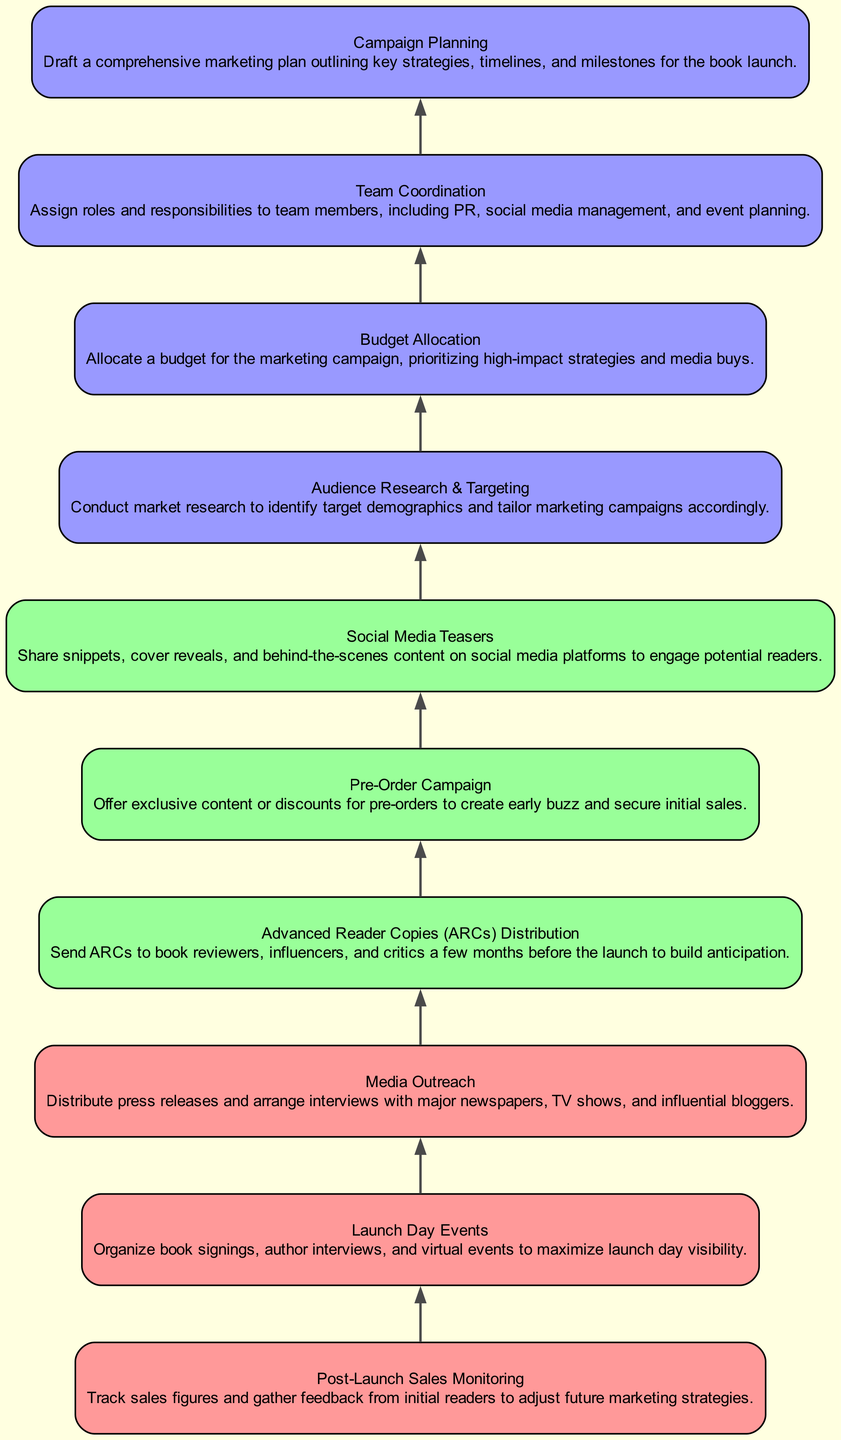What is the first step in the workflow? The first step in the workflow is found at the bottom of the flow chart, which is "Campaign Planning." This step outlines the marketing plan before any actions are taken.
Answer: Campaign Planning How many total nodes are in the diagram? To count the total nodes, we can look at the individual steps listed. There are ten steps from "Campaign Planning" to "Post-Launch Sales Monitoring," indicating there are ten nodes in total.
Answer: Ten Which step follows "Media Outreach"? "Advanced Reader Copies (ARCs) Distribution" immediately follows "Media Outreach" in the flow chart, suggesting that these actions are sequential in the marketing campaign workflow.
Answer: Advanced Reader Copies (ARCs) Distribution What color is used for the final steps of the workflow? The final steps, specifically the last three nodes of the chart, are colored light red, indicating that they are important final actions to be taken after pre-launch activities.
Answer: Light red Which step involves assigning roles to team members? The step titled "Team Coordination" is responsible for assigning roles and responsibilities to team members, ensuring clear delineation of tasks before the launch.
Answer: Team Coordination What type of event is planned on launch day? The flow chart indicates that there are "Launch Day Events," which involve book signings and author interviews to maximize visibility on the launch day.
Answer: Launch Day Events Which steps of the workflow are categorized as pre-launch activities? The first five steps leading up to "Media Outreach" are categorized as pre-launch activities, including "Campaign Planning," "Team Coordination," "Budget Allocation," "Audience Research & Targeting," and "Social Media Teasers."
Answer: First five steps How does "Budget Allocation" relate to other steps in the workflow? "Budget Allocation" is positioned in the chart as a foundational step that informs the financial resources available for subsequent marketing strategies, including media outreach and audience targeting.
Answer: Foundational step What is the purpose of "Post-Launch Sales Monitoring"? The purpose of "Post-Launch Sales Monitoring" is to track sales figures and gather initial reader feedback to make necessary adjustments for future marketing strategies after the launch has occurred.
Answer: Track sales figures 